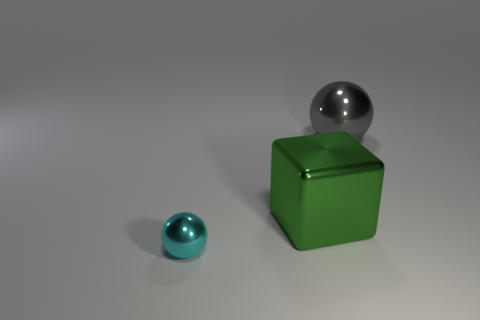Is the number of small cyan metal objects that are to the right of the gray shiny sphere the same as the number of big rubber cubes? Indeed, the quantity matches; one small cyan metal object is to the right of the gray shiny sphere, corresponding to the single large rubber cube present in the scene. 